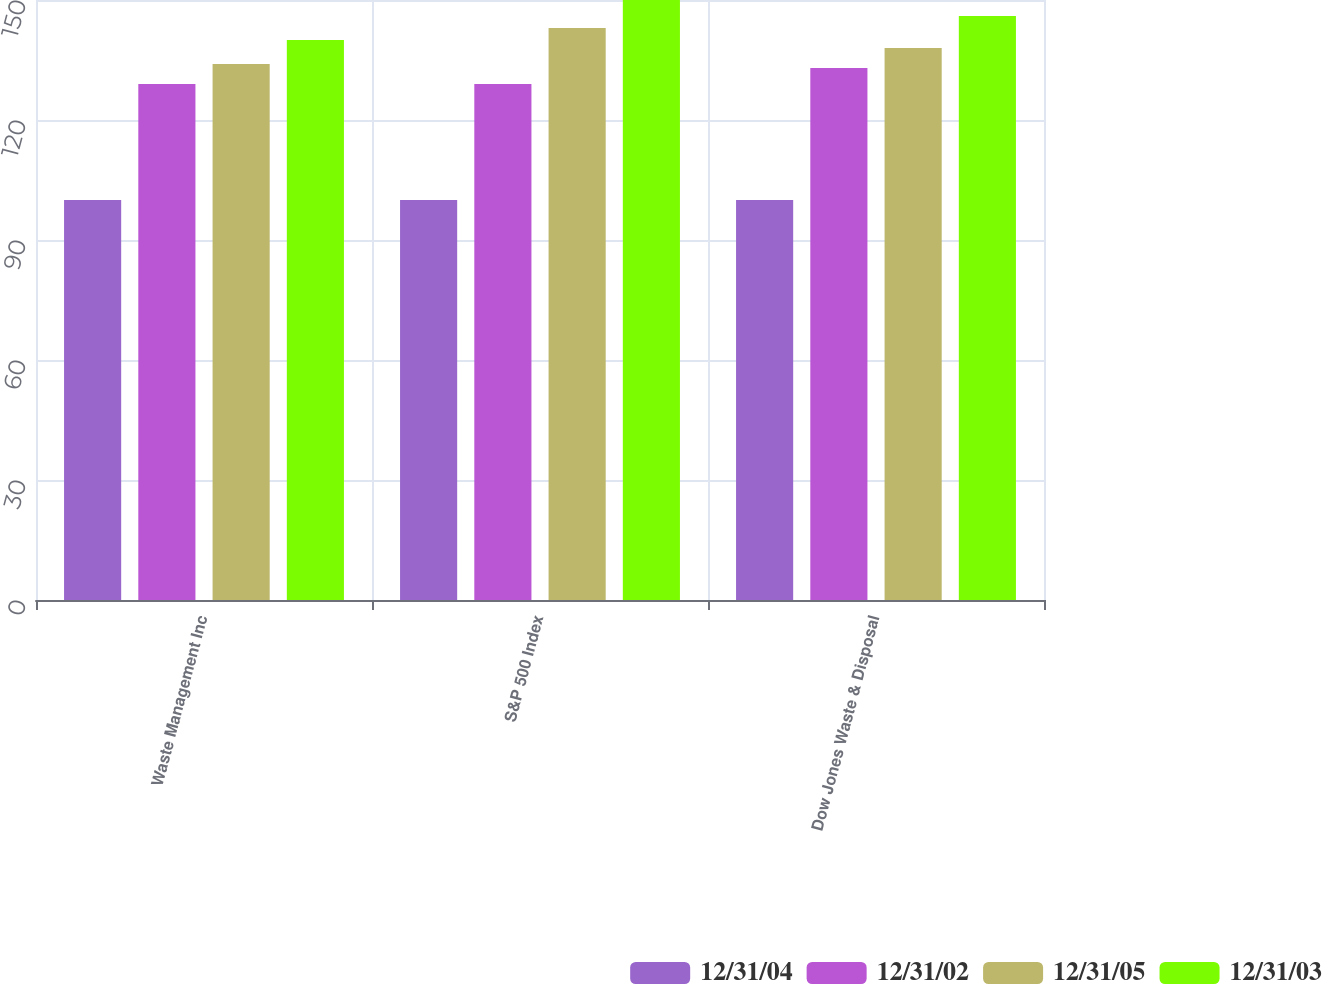Convert chart to OTSL. <chart><loc_0><loc_0><loc_500><loc_500><stacked_bar_chart><ecel><fcel>Waste Management Inc<fcel>S&P 500 Index<fcel>Dow Jones Waste & Disposal<nl><fcel>12/31/04<fcel>100<fcel>100<fcel>100<nl><fcel>12/31/02<fcel>129<fcel>129<fcel>133<nl><fcel>12/31/05<fcel>134<fcel>143<fcel>138<nl><fcel>12/31/03<fcel>140<fcel>150<fcel>146<nl></chart> 